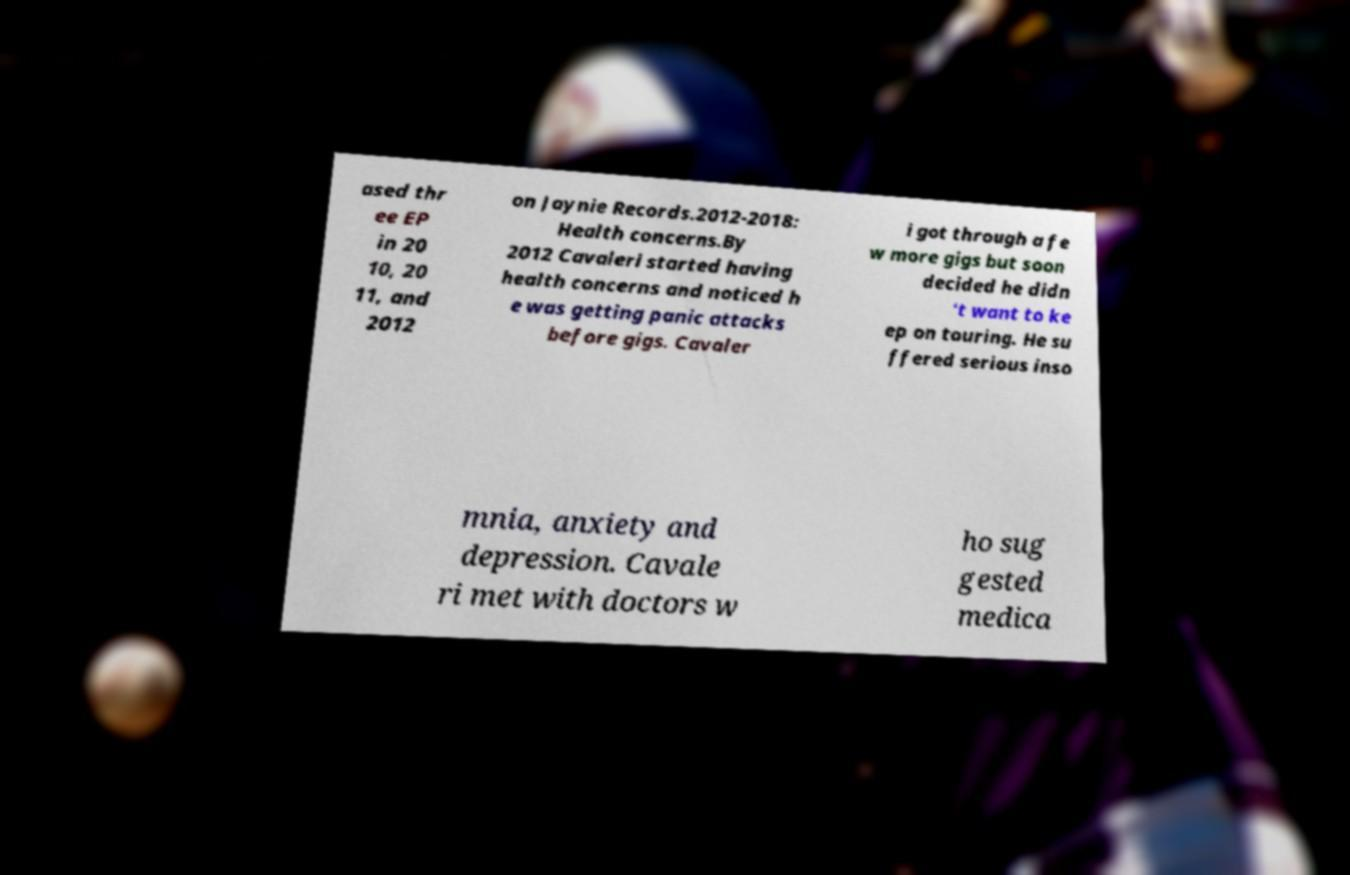For documentation purposes, I need the text within this image transcribed. Could you provide that? ased thr ee EP in 20 10, 20 11, and 2012 on Jaynie Records.2012-2018: Health concerns.By 2012 Cavaleri started having health concerns and noticed h e was getting panic attacks before gigs. Cavaler i got through a fe w more gigs but soon decided he didn 't want to ke ep on touring. He su ffered serious inso mnia, anxiety and depression. Cavale ri met with doctors w ho sug gested medica 